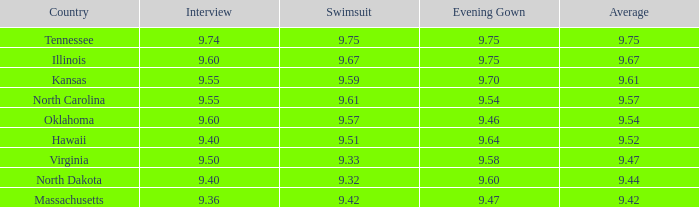74 score? 9.75. 